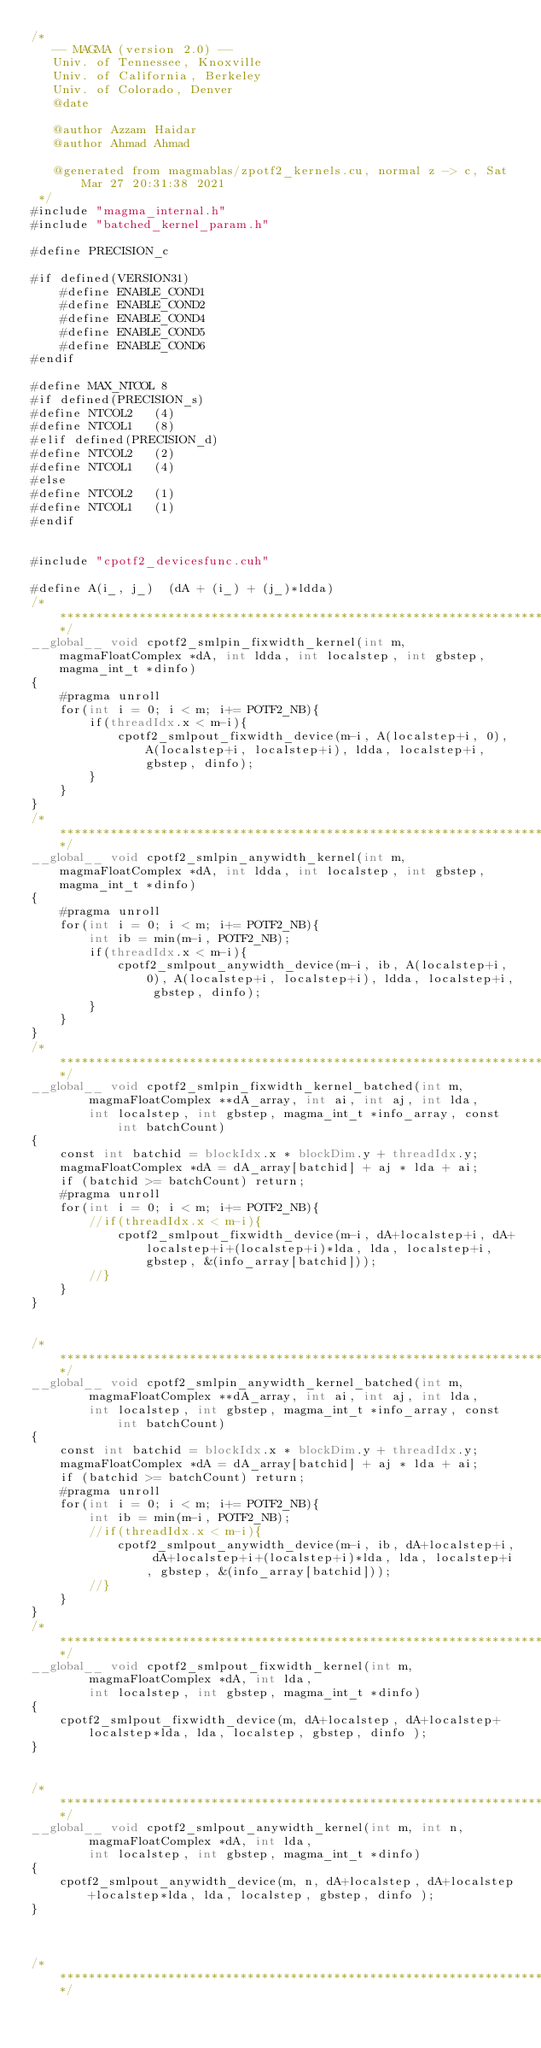Convert code to text. <code><loc_0><loc_0><loc_500><loc_500><_Cuda_>/*
   -- MAGMA (version 2.0) --
   Univ. of Tennessee, Knoxville
   Univ. of California, Berkeley
   Univ. of Colorado, Denver
   @date

   @author Azzam Haidar
   @author Ahmad Ahmad

   @generated from magmablas/zpotf2_kernels.cu, normal z -> c, Sat Mar 27 20:31:38 2021
 */
#include "magma_internal.h"
#include "batched_kernel_param.h"

#define PRECISION_c

#if defined(VERSION31)
    #define ENABLE_COND1
    #define ENABLE_COND2
    #define ENABLE_COND4
    #define ENABLE_COND5
    #define ENABLE_COND6
#endif

#define MAX_NTCOL 8
#if defined(PRECISION_s)
#define NTCOL2   (4)
#define NTCOL1   (8)
#elif defined(PRECISION_d)
#define NTCOL2   (2)
#define NTCOL1   (4)
#else
#define NTCOL2   (1)
#define NTCOL1   (1)
#endif


#include "cpotf2_devicesfunc.cuh"

#define A(i_, j_)  (dA + (i_) + (j_)*ldda)
/******************************************************************************/
__global__ void cpotf2_smlpin_fixwidth_kernel(int m, magmaFloatComplex *dA, int ldda, int localstep, int gbstep, magma_int_t *dinfo)
{
    #pragma unroll
    for(int i = 0; i < m; i+= POTF2_NB){
        if(threadIdx.x < m-i){
            cpotf2_smlpout_fixwidth_device(m-i, A(localstep+i, 0), A(localstep+i, localstep+i), ldda, localstep+i, gbstep, dinfo);
        }
    }
}
/******************************************************************************/
__global__ void cpotf2_smlpin_anywidth_kernel(int m, magmaFloatComplex *dA, int ldda, int localstep, int gbstep, magma_int_t *dinfo)
{
    #pragma unroll
    for(int i = 0; i < m; i+= POTF2_NB){
        int ib = min(m-i, POTF2_NB);
        if(threadIdx.x < m-i){
            cpotf2_smlpout_anywidth_device(m-i, ib, A(localstep+i, 0), A(localstep+i, localstep+i), ldda, localstep+i, gbstep, dinfo);
        }
    }
}
/******************************************************************************/
__global__ void cpotf2_smlpin_fixwidth_kernel_batched(int m,
        magmaFloatComplex **dA_array, int ai, int aj, int lda,
        int localstep, int gbstep, magma_int_t *info_array, const int batchCount)
{
    const int batchid = blockIdx.x * blockDim.y + threadIdx.y;
    magmaFloatComplex *dA = dA_array[batchid] + aj * lda + ai;
    if (batchid >= batchCount) return;
    #pragma unroll
    for(int i = 0; i < m; i+= POTF2_NB){
        //if(threadIdx.x < m-i){
            cpotf2_smlpout_fixwidth_device(m-i, dA+localstep+i, dA+localstep+i+(localstep+i)*lda, lda, localstep+i, gbstep, &(info_array[batchid]));
        //}
    }
}


/******************************************************************************/
__global__ void cpotf2_smlpin_anywidth_kernel_batched(int m,
        magmaFloatComplex **dA_array, int ai, int aj, int lda,
        int localstep, int gbstep, magma_int_t *info_array, const int batchCount)
{
    const int batchid = blockIdx.x * blockDim.y + threadIdx.y;
    magmaFloatComplex *dA = dA_array[batchid] + aj * lda + ai;
    if (batchid >= batchCount) return;
    #pragma unroll
    for(int i = 0; i < m; i+= POTF2_NB){
        int ib = min(m-i, POTF2_NB);
        //if(threadIdx.x < m-i){
            cpotf2_smlpout_anywidth_device(m-i, ib, dA+localstep+i, dA+localstep+i+(localstep+i)*lda, lda, localstep+i, gbstep, &(info_array[batchid]));
        //}
    }
}
/******************************************************************************/
__global__ void cpotf2_smlpout_fixwidth_kernel(int m,
        magmaFloatComplex *dA, int lda,
        int localstep, int gbstep, magma_int_t *dinfo)
{
    cpotf2_smlpout_fixwidth_device(m, dA+localstep, dA+localstep+localstep*lda, lda, localstep, gbstep, dinfo );
}


/******************************************************************************/
__global__ void cpotf2_smlpout_anywidth_kernel(int m, int n,
        magmaFloatComplex *dA, int lda,
        int localstep, int gbstep, magma_int_t *dinfo)
{
    cpotf2_smlpout_anywidth_device(m, n, dA+localstep, dA+localstep+localstep*lda, lda, localstep, gbstep, dinfo );
}



/******************************************************************************/</code> 